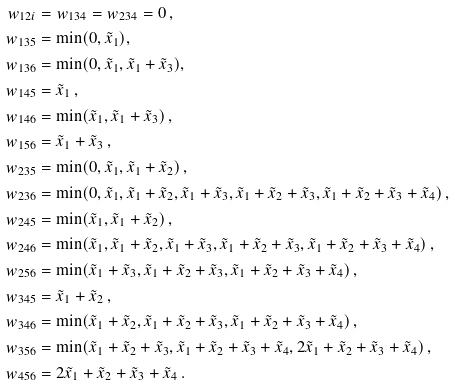Convert formula to latex. <formula><loc_0><loc_0><loc_500><loc_500>w _ { 1 2 i } & = w _ { 1 3 4 } = w _ { 2 3 4 } = 0 \, , \\ w _ { 1 3 5 } & = \min ( 0 , \tilde { x } _ { 1 } ) , \quad \\ w _ { 1 3 6 } & = \min ( 0 , \tilde { x } _ { 1 } , \tilde { x } _ { 1 } + \tilde { x } _ { 3 } ) , \quad \\ w _ { 1 4 5 } & = \tilde { x } _ { 1 } \, , \\ w _ { 1 4 6 } & = \min ( \tilde { x } _ { 1 } , \tilde { x } _ { 1 } + \tilde { x } _ { 3 } ) \, , \\ w _ { 1 5 6 } & = \tilde { x } _ { 1 } + \tilde { x } _ { 3 } \, , \\ w _ { 2 3 5 } & = \min ( 0 , \tilde { x } _ { 1 } , \tilde { x } _ { 1 } + \tilde { x } _ { 2 } ) \, , \\ w _ { 2 3 6 } & = \min ( 0 , \tilde { x } _ { 1 } , \tilde { x } _ { 1 } + \tilde { x } _ { 2 } , \tilde { x } _ { 1 } + \tilde { x } _ { 3 } , \tilde { x } _ { 1 } + \tilde { x } _ { 2 } + \tilde { x } _ { 3 } , \tilde { x } _ { 1 } + \tilde { x } _ { 2 } + \tilde { x } _ { 3 } + \tilde { x } _ { 4 } ) \, , \\ w _ { 2 4 5 } & = \min ( \tilde { x } _ { 1 } , \tilde { x } _ { 1 } + \tilde { x } _ { 2 } ) \, , \\ w _ { 2 4 6 } & = \min ( \tilde { x } _ { 1 } , \tilde { x } _ { 1 } + \tilde { x } _ { 2 } , \tilde { x } _ { 1 } + \tilde { x } _ { 3 } , \tilde { x } _ { 1 } + \tilde { x } _ { 2 } + \tilde { x } _ { 3 } , \tilde { x } _ { 1 } + \tilde { x } _ { 2 } + \tilde { x } _ { 3 } + \tilde { x } _ { 4 } ) \, , \\ w _ { 2 5 6 } & = \min ( \tilde { x } _ { 1 } + \tilde { x } _ { 3 } , \tilde { x } _ { 1 } + \tilde { x } _ { 2 } + \tilde { x } _ { 3 } , \tilde { x } _ { 1 } + \tilde { x } _ { 2 } + \tilde { x } _ { 3 } + \tilde { x } _ { 4 } ) \, , \\ w _ { 3 4 5 } & = \tilde { x } _ { 1 } + \tilde { x } _ { 2 } \, , \\ w _ { 3 4 6 } & = \min ( \tilde { x } _ { 1 } + \tilde { x } _ { 2 } , \tilde { x } _ { 1 } + \tilde { x } _ { 2 } + \tilde { x } _ { 3 } , \tilde { x } _ { 1 } + \tilde { x } _ { 2 } + \tilde { x } _ { 3 } + \tilde { x } _ { 4 } ) \, , \\ w _ { 3 5 6 } & = \min ( \tilde { x } _ { 1 } + \tilde { x } _ { 2 } + \tilde { x } _ { 3 } , \tilde { x } _ { 1 } + \tilde { x } _ { 2 } + \tilde { x } _ { 3 } + \tilde { x } _ { 4 } , 2 \tilde { x } _ { 1 } + \tilde { x } _ { 2 } + \tilde { x } _ { 3 } + \tilde { x } _ { 4 } ) \, , \\ w _ { 4 5 6 } & = 2 \tilde { x } _ { 1 } + \tilde { x } _ { 2 } + \tilde { x } _ { 3 } + \tilde { x } _ { 4 } \, .</formula> 